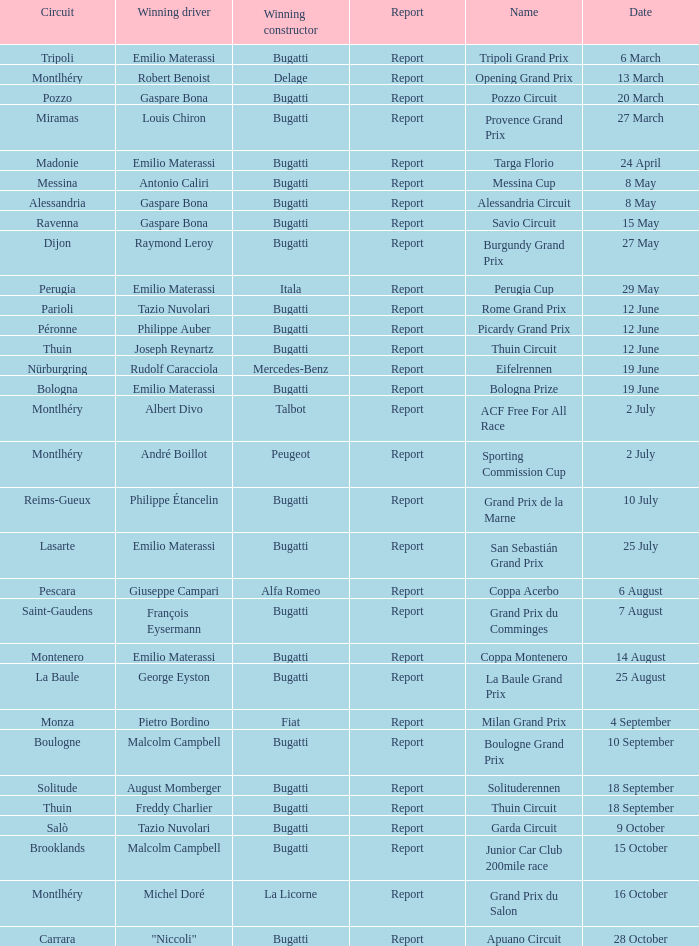Who was the winning constructor of the Grand Prix Du Salon ? La Licorne. 